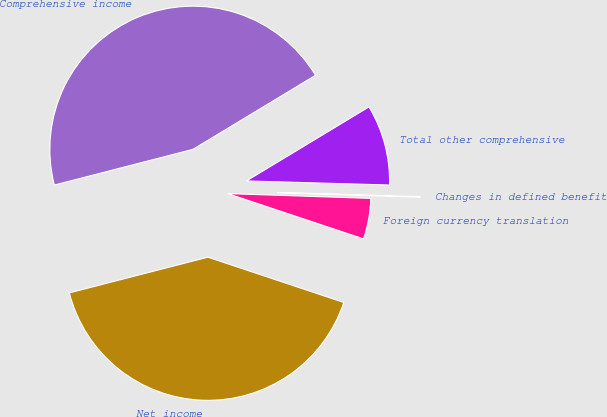Convert chart to OTSL. <chart><loc_0><loc_0><loc_500><loc_500><pie_chart><fcel>Net income<fcel>Foreign currency translation<fcel>Changes in defined benefit<fcel>Total other comprehensive<fcel>Comprehensive income<nl><fcel>40.86%<fcel>4.59%<fcel>0.08%<fcel>9.1%<fcel>45.36%<nl></chart> 